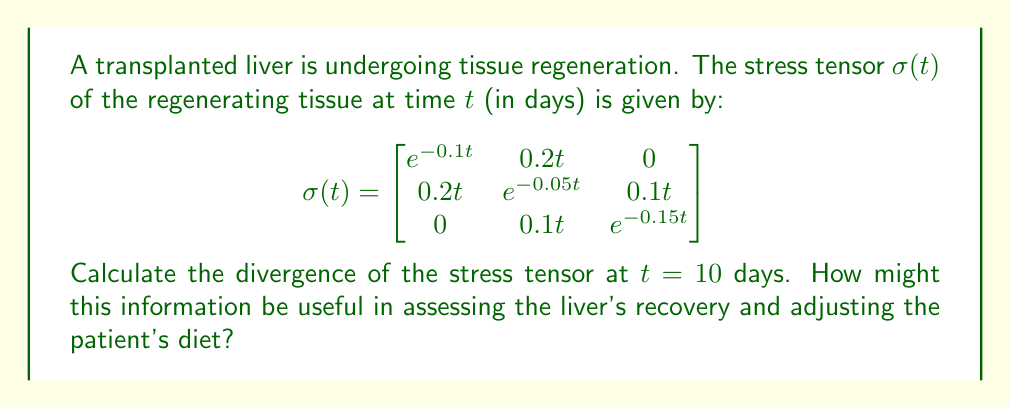Can you answer this question? To solve this problem, we need to follow these steps:

1) The divergence of a tensor $\sigma$ in 3D space is given by:

   $$\text{div}(\sigma) = \nabla \cdot \sigma = \frac{\partial \sigma_{11}}{\partial x} + \frac{\partial \sigma_{22}}{\partial y} + \frac{\partial \sigma_{33}}{\partial z}$$

2) In our case, we're dealing with time derivatives instead of spatial derivatives. So we need to calculate:

   $$\text{div}(\sigma) = \frac{\partial \sigma_{11}}{\partial t} + \frac{\partial \sigma_{22}}{\partial t} + \frac{\partial \sigma_{33}}{\partial t}$$

3) Let's calculate each term:

   $\frac{\partial \sigma_{11}}{\partial t} = \frac{\partial}{\partial t}(e^{-0.1t}) = -0.1e^{-0.1t}$

   $\frac{\partial \sigma_{22}}{\partial t} = \frac{\partial}{\partial t}(e^{-0.05t}) = -0.05e^{-0.05t}$

   $\frac{\partial \sigma_{33}}{\partial t} = \frac{\partial}{\partial t}(e^{-0.15t}) = -0.15e^{-0.15t}$

4) Now, we sum these terms:

   $\text{div}(\sigma) = -0.1e^{-0.1t} - 0.05e^{-0.05t} - 0.15e^{-0.15t}$

5) We need to evaluate this at $t = 10$:

   $\text{div}(\sigma)|_{t=10} = -0.1e^{-1} - 0.05e^{-0.5} - 0.15e^{-1.5}$

6) Calculate the numerical value:

   $\text{div}(\sigma)|_{t=10} \approx -0.0368 - 0.0303 - 0.0335 = -0.1006$

This negative divergence indicates that the stress in the liver tissue is decreasing over time, which is generally a good sign for tissue regeneration. A transplant surgeon and dietitian could use this information to assess the liver's recovery rate and adjust the patient's diet accordingly. For instance, if the stress reduction is slower than expected, they might consider increasing nutrients that support liver regeneration in the patient's diet.
Answer: $-0.1006$ 